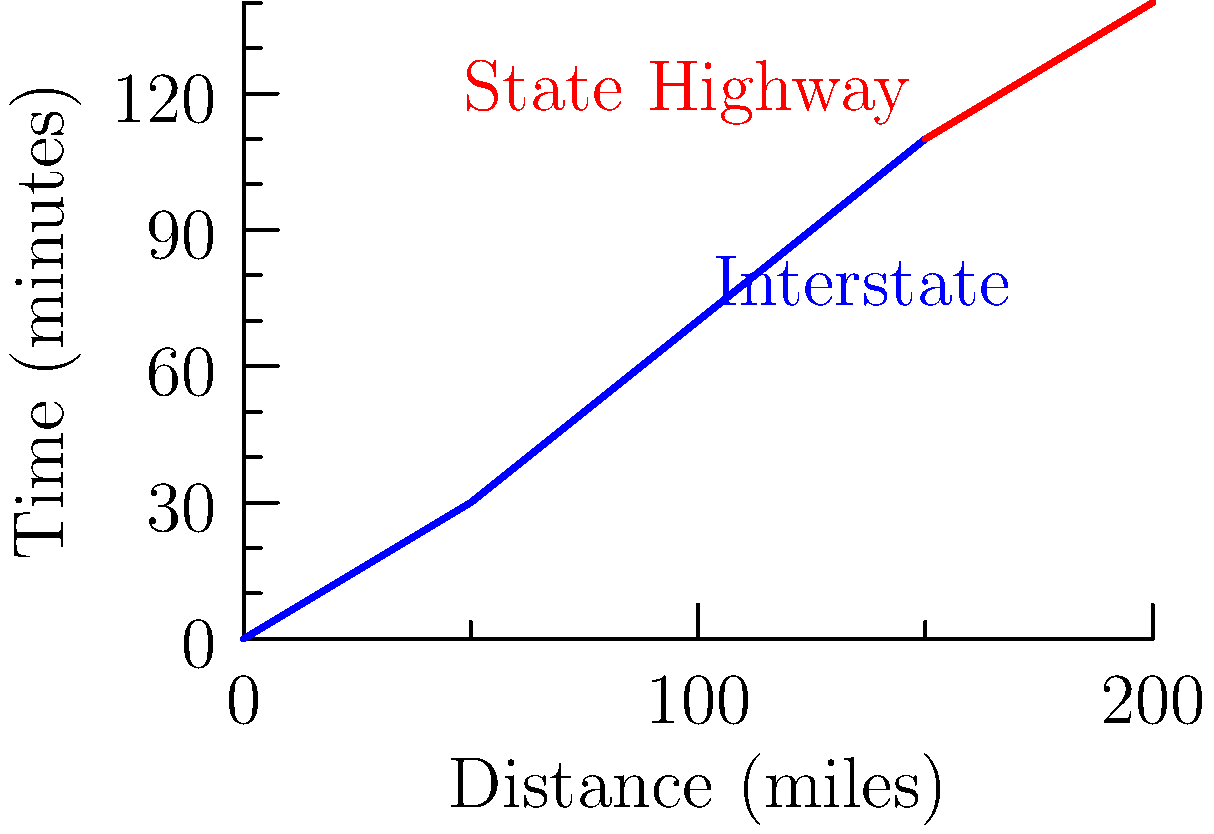A road tripper plans a journey that includes 150 miles on an Interstate followed by 50 miles on a State Highway. Using the graph, which shows travel time based on distance for different road types, estimate the total travel time for this trip in hours and minutes. Let's break this down step-by-step:

1. For the Interstate portion:
   - From the blue line (Interstate), we can see that 150 miles corresponds to about 110 minutes.

2. For the State Highway portion:
   - The red line (State Highway) starts at 150 miles.
   - We need to find the time for an additional 50 miles (from 150 to 200).
   - At 200 miles, the time is about 140 minutes.
   - At 150 miles, the time is about 110 minutes.
   - So, the additional time is: 140 - 110 = 30 minutes.

3. Total time calculation:
   - Interstate time: 110 minutes
   - State Highway time: 30 minutes
   - Total: 110 + 30 = 140 minutes

4. Converting to hours and minutes:
   - 140 minutes = 2 hours and 20 minutes
   
   $140 \div 60 = 2$ remainder $20$
   
   Therefore, the total estimated travel time is 2 hours and 20 minutes.
Answer: 2 hours and 20 minutes 